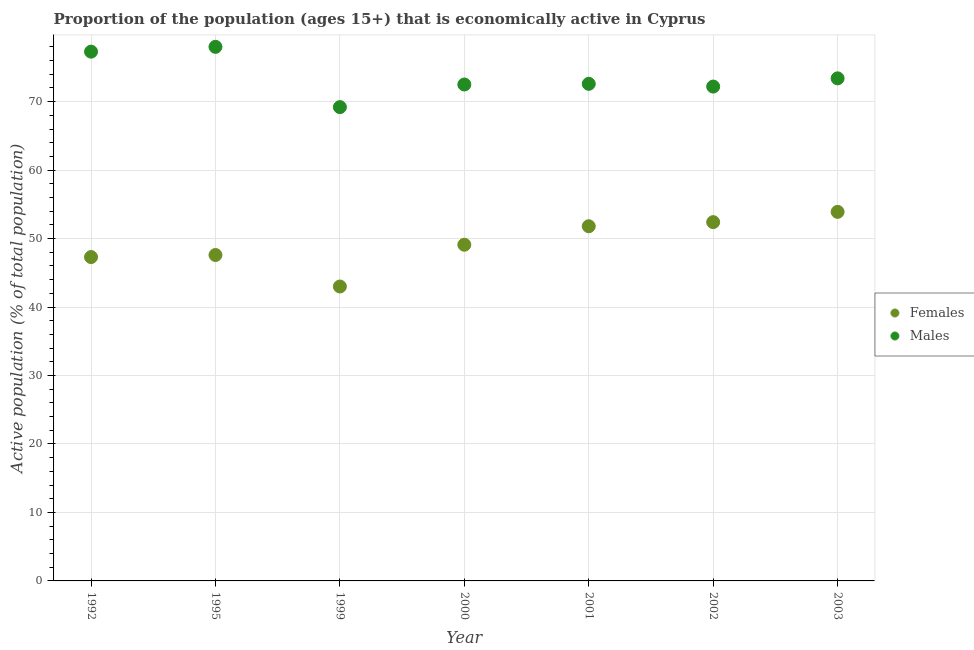Is the number of dotlines equal to the number of legend labels?
Offer a terse response. Yes. What is the percentage of economically active male population in 1999?
Provide a short and direct response. 69.2. Across all years, what is the maximum percentage of economically active female population?
Your response must be concise. 53.9. Across all years, what is the minimum percentage of economically active male population?
Your answer should be compact. 69.2. In which year was the percentage of economically active male population maximum?
Ensure brevity in your answer.  1995. In which year was the percentage of economically active male population minimum?
Keep it short and to the point. 1999. What is the total percentage of economically active male population in the graph?
Give a very brief answer. 515.2. What is the difference between the percentage of economically active male population in 1995 and that in 2003?
Offer a terse response. 4.6. What is the difference between the percentage of economically active female population in 2002 and the percentage of economically active male population in 2000?
Ensure brevity in your answer.  -20.1. What is the average percentage of economically active female population per year?
Make the answer very short. 49.3. In the year 1995, what is the difference between the percentage of economically active female population and percentage of economically active male population?
Offer a very short reply. -30.4. What is the ratio of the percentage of economically active female population in 1992 to that in 2002?
Offer a terse response. 0.9. What is the difference between the highest and the second highest percentage of economically active male population?
Your answer should be compact. 0.7. What is the difference between the highest and the lowest percentage of economically active male population?
Provide a short and direct response. 8.8. In how many years, is the percentage of economically active male population greater than the average percentage of economically active male population taken over all years?
Offer a terse response. 2. Is the sum of the percentage of economically active female population in 1992 and 2002 greater than the maximum percentage of economically active male population across all years?
Ensure brevity in your answer.  Yes. Does the percentage of economically active female population monotonically increase over the years?
Your response must be concise. No. Is the percentage of economically active female population strictly greater than the percentage of economically active male population over the years?
Your response must be concise. No. What is the difference between two consecutive major ticks on the Y-axis?
Ensure brevity in your answer.  10. Are the values on the major ticks of Y-axis written in scientific E-notation?
Provide a short and direct response. No. Does the graph contain any zero values?
Your answer should be very brief. No. Where does the legend appear in the graph?
Offer a terse response. Center right. What is the title of the graph?
Offer a very short reply. Proportion of the population (ages 15+) that is economically active in Cyprus. What is the label or title of the X-axis?
Offer a very short reply. Year. What is the label or title of the Y-axis?
Keep it short and to the point. Active population (% of total population). What is the Active population (% of total population) of Females in 1992?
Offer a terse response. 47.3. What is the Active population (% of total population) in Males in 1992?
Offer a very short reply. 77.3. What is the Active population (% of total population) in Females in 1995?
Offer a terse response. 47.6. What is the Active population (% of total population) in Females in 1999?
Your answer should be very brief. 43. What is the Active population (% of total population) in Males in 1999?
Your answer should be very brief. 69.2. What is the Active population (% of total population) in Females in 2000?
Keep it short and to the point. 49.1. What is the Active population (% of total population) in Males in 2000?
Provide a short and direct response. 72.5. What is the Active population (% of total population) in Females in 2001?
Your response must be concise. 51.8. What is the Active population (% of total population) in Males in 2001?
Give a very brief answer. 72.6. What is the Active population (% of total population) of Females in 2002?
Ensure brevity in your answer.  52.4. What is the Active population (% of total population) of Males in 2002?
Offer a very short reply. 72.2. What is the Active population (% of total population) of Females in 2003?
Your response must be concise. 53.9. What is the Active population (% of total population) in Males in 2003?
Provide a short and direct response. 73.4. Across all years, what is the maximum Active population (% of total population) in Females?
Give a very brief answer. 53.9. Across all years, what is the maximum Active population (% of total population) of Males?
Give a very brief answer. 78. Across all years, what is the minimum Active population (% of total population) in Females?
Your response must be concise. 43. Across all years, what is the minimum Active population (% of total population) in Males?
Provide a short and direct response. 69.2. What is the total Active population (% of total population) in Females in the graph?
Ensure brevity in your answer.  345.1. What is the total Active population (% of total population) in Males in the graph?
Your answer should be compact. 515.2. What is the difference between the Active population (% of total population) of Females in 1992 and that in 1995?
Make the answer very short. -0.3. What is the difference between the Active population (% of total population) in Males in 1992 and that in 1995?
Make the answer very short. -0.7. What is the difference between the Active population (% of total population) in Males in 1992 and that in 1999?
Offer a terse response. 8.1. What is the difference between the Active population (% of total population) in Females in 1992 and that in 2002?
Make the answer very short. -5.1. What is the difference between the Active population (% of total population) of Males in 1992 and that in 2002?
Make the answer very short. 5.1. What is the difference between the Active population (% of total population) in Males in 1992 and that in 2003?
Offer a very short reply. 3.9. What is the difference between the Active population (% of total population) in Females in 1995 and that in 1999?
Make the answer very short. 4.6. What is the difference between the Active population (% of total population) in Females in 1995 and that in 2000?
Keep it short and to the point. -1.5. What is the difference between the Active population (% of total population) of Males in 1995 and that in 2001?
Offer a terse response. 5.4. What is the difference between the Active population (% of total population) of Females in 1995 and that in 2002?
Make the answer very short. -4.8. What is the difference between the Active population (% of total population) of Males in 1999 and that in 2003?
Provide a succinct answer. -4.2. What is the difference between the Active population (% of total population) in Males in 2000 and that in 2002?
Ensure brevity in your answer.  0.3. What is the difference between the Active population (% of total population) in Females in 2000 and that in 2003?
Offer a terse response. -4.8. What is the difference between the Active population (% of total population) of Males in 2000 and that in 2003?
Provide a succinct answer. -0.9. What is the difference between the Active population (% of total population) in Females in 2001 and that in 2002?
Make the answer very short. -0.6. What is the difference between the Active population (% of total population) of Males in 2001 and that in 2002?
Provide a short and direct response. 0.4. What is the difference between the Active population (% of total population) in Females in 2001 and that in 2003?
Your answer should be very brief. -2.1. What is the difference between the Active population (% of total population) in Males in 2001 and that in 2003?
Your response must be concise. -0.8. What is the difference between the Active population (% of total population) in Females in 2002 and that in 2003?
Provide a short and direct response. -1.5. What is the difference between the Active population (% of total population) of Females in 1992 and the Active population (% of total population) of Males in 1995?
Offer a very short reply. -30.7. What is the difference between the Active population (% of total population) in Females in 1992 and the Active population (% of total population) in Males in 1999?
Your response must be concise. -21.9. What is the difference between the Active population (% of total population) in Females in 1992 and the Active population (% of total population) in Males in 2000?
Give a very brief answer. -25.2. What is the difference between the Active population (% of total population) in Females in 1992 and the Active population (% of total population) in Males in 2001?
Your answer should be very brief. -25.3. What is the difference between the Active population (% of total population) of Females in 1992 and the Active population (% of total population) of Males in 2002?
Your answer should be compact. -24.9. What is the difference between the Active population (% of total population) in Females in 1992 and the Active population (% of total population) in Males in 2003?
Your answer should be very brief. -26.1. What is the difference between the Active population (% of total population) of Females in 1995 and the Active population (% of total population) of Males in 1999?
Ensure brevity in your answer.  -21.6. What is the difference between the Active population (% of total population) of Females in 1995 and the Active population (% of total population) of Males in 2000?
Give a very brief answer. -24.9. What is the difference between the Active population (% of total population) in Females in 1995 and the Active population (% of total population) in Males in 2002?
Provide a succinct answer. -24.6. What is the difference between the Active population (% of total population) in Females in 1995 and the Active population (% of total population) in Males in 2003?
Make the answer very short. -25.8. What is the difference between the Active population (% of total population) in Females in 1999 and the Active population (% of total population) in Males in 2000?
Offer a very short reply. -29.5. What is the difference between the Active population (% of total population) of Females in 1999 and the Active population (% of total population) of Males in 2001?
Give a very brief answer. -29.6. What is the difference between the Active population (% of total population) in Females in 1999 and the Active population (% of total population) in Males in 2002?
Keep it short and to the point. -29.2. What is the difference between the Active population (% of total population) in Females in 1999 and the Active population (% of total population) in Males in 2003?
Provide a succinct answer. -30.4. What is the difference between the Active population (% of total population) of Females in 2000 and the Active population (% of total population) of Males in 2001?
Make the answer very short. -23.5. What is the difference between the Active population (% of total population) in Females in 2000 and the Active population (% of total population) in Males in 2002?
Make the answer very short. -23.1. What is the difference between the Active population (% of total population) in Females in 2000 and the Active population (% of total population) in Males in 2003?
Ensure brevity in your answer.  -24.3. What is the difference between the Active population (% of total population) of Females in 2001 and the Active population (% of total population) of Males in 2002?
Ensure brevity in your answer.  -20.4. What is the difference between the Active population (% of total population) in Females in 2001 and the Active population (% of total population) in Males in 2003?
Provide a succinct answer. -21.6. What is the difference between the Active population (% of total population) of Females in 2002 and the Active population (% of total population) of Males in 2003?
Make the answer very short. -21. What is the average Active population (% of total population) of Females per year?
Offer a terse response. 49.3. What is the average Active population (% of total population) in Males per year?
Your answer should be compact. 73.6. In the year 1995, what is the difference between the Active population (% of total population) in Females and Active population (% of total population) in Males?
Make the answer very short. -30.4. In the year 1999, what is the difference between the Active population (% of total population) of Females and Active population (% of total population) of Males?
Your answer should be very brief. -26.2. In the year 2000, what is the difference between the Active population (% of total population) in Females and Active population (% of total population) in Males?
Give a very brief answer. -23.4. In the year 2001, what is the difference between the Active population (% of total population) in Females and Active population (% of total population) in Males?
Give a very brief answer. -20.8. In the year 2002, what is the difference between the Active population (% of total population) in Females and Active population (% of total population) in Males?
Provide a succinct answer. -19.8. In the year 2003, what is the difference between the Active population (% of total population) in Females and Active population (% of total population) in Males?
Give a very brief answer. -19.5. What is the ratio of the Active population (% of total population) in Females in 1992 to that in 1995?
Provide a succinct answer. 0.99. What is the ratio of the Active population (% of total population) in Males in 1992 to that in 1999?
Your answer should be very brief. 1.12. What is the ratio of the Active population (% of total population) in Females in 1992 to that in 2000?
Give a very brief answer. 0.96. What is the ratio of the Active population (% of total population) in Males in 1992 to that in 2000?
Ensure brevity in your answer.  1.07. What is the ratio of the Active population (% of total population) of Females in 1992 to that in 2001?
Your response must be concise. 0.91. What is the ratio of the Active population (% of total population) in Males in 1992 to that in 2001?
Offer a very short reply. 1.06. What is the ratio of the Active population (% of total population) of Females in 1992 to that in 2002?
Provide a short and direct response. 0.9. What is the ratio of the Active population (% of total population) in Males in 1992 to that in 2002?
Keep it short and to the point. 1.07. What is the ratio of the Active population (% of total population) of Females in 1992 to that in 2003?
Your response must be concise. 0.88. What is the ratio of the Active population (% of total population) in Males in 1992 to that in 2003?
Make the answer very short. 1.05. What is the ratio of the Active population (% of total population) of Females in 1995 to that in 1999?
Offer a terse response. 1.11. What is the ratio of the Active population (% of total population) of Males in 1995 to that in 1999?
Give a very brief answer. 1.13. What is the ratio of the Active population (% of total population) in Females in 1995 to that in 2000?
Your answer should be very brief. 0.97. What is the ratio of the Active population (% of total population) of Males in 1995 to that in 2000?
Give a very brief answer. 1.08. What is the ratio of the Active population (% of total population) of Females in 1995 to that in 2001?
Keep it short and to the point. 0.92. What is the ratio of the Active population (% of total population) in Males in 1995 to that in 2001?
Keep it short and to the point. 1.07. What is the ratio of the Active population (% of total population) of Females in 1995 to that in 2002?
Your answer should be compact. 0.91. What is the ratio of the Active population (% of total population) in Males in 1995 to that in 2002?
Your answer should be compact. 1.08. What is the ratio of the Active population (% of total population) in Females in 1995 to that in 2003?
Provide a succinct answer. 0.88. What is the ratio of the Active population (% of total population) in Males in 1995 to that in 2003?
Offer a very short reply. 1.06. What is the ratio of the Active population (% of total population) in Females in 1999 to that in 2000?
Your answer should be compact. 0.88. What is the ratio of the Active population (% of total population) in Males in 1999 to that in 2000?
Your answer should be very brief. 0.95. What is the ratio of the Active population (% of total population) in Females in 1999 to that in 2001?
Make the answer very short. 0.83. What is the ratio of the Active population (% of total population) of Males in 1999 to that in 2001?
Your response must be concise. 0.95. What is the ratio of the Active population (% of total population) in Females in 1999 to that in 2002?
Give a very brief answer. 0.82. What is the ratio of the Active population (% of total population) of Males in 1999 to that in 2002?
Your answer should be compact. 0.96. What is the ratio of the Active population (% of total population) of Females in 1999 to that in 2003?
Your answer should be very brief. 0.8. What is the ratio of the Active population (% of total population) in Males in 1999 to that in 2003?
Your response must be concise. 0.94. What is the ratio of the Active population (% of total population) in Females in 2000 to that in 2001?
Give a very brief answer. 0.95. What is the ratio of the Active population (% of total population) of Males in 2000 to that in 2001?
Make the answer very short. 1. What is the ratio of the Active population (% of total population) of Females in 2000 to that in 2002?
Keep it short and to the point. 0.94. What is the ratio of the Active population (% of total population) in Females in 2000 to that in 2003?
Provide a succinct answer. 0.91. What is the ratio of the Active population (% of total population) in Males in 2000 to that in 2003?
Provide a short and direct response. 0.99. What is the ratio of the Active population (% of total population) in Females in 2001 to that in 2002?
Provide a short and direct response. 0.99. What is the ratio of the Active population (% of total population) in Males in 2001 to that in 2003?
Give a very brief answer. 0.99. What is the ratio of the Active population (% of total population) in Females in 2002 to that in 2003?
Your answer should be very brief. 0.97. What is the ratio of the Active population (% of total population) of Males in 2002 to that in 2003?
Your answer should be compact. 0.98. What is the difference between the highest and the second highest Active population (% of total population) in Males?
Your answer should be compact. 0.7. What is the difference between the highest and the lowest Active population (% of total population) of Females?
Your response must be concise. 10.9. 